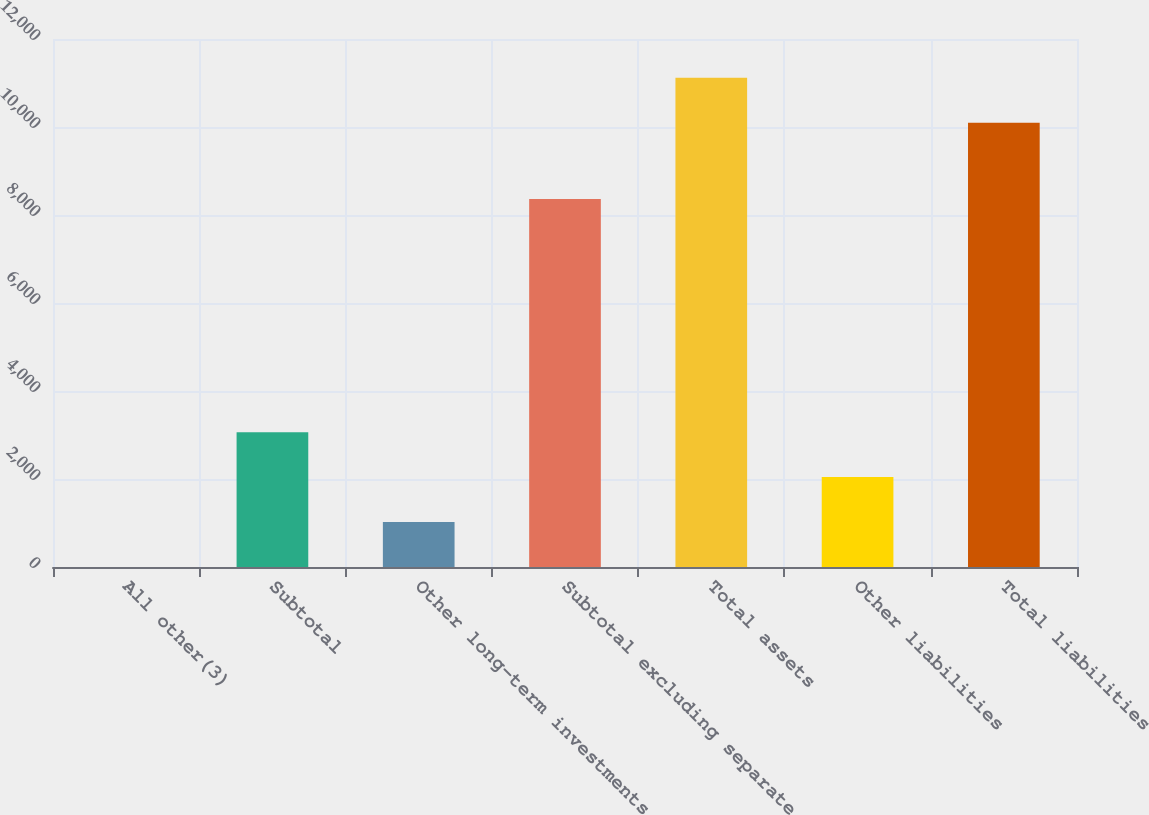Convert chart. <chart><loc_0><loc_0><loc_500><loc_500><bar_chart><fcel>All other(3)<fcel>Subtotal<fcel>Other long-term investments<fcel>Subtotal excluding separate<fcel>Total assets<fcel>Other liabilities<fcel>Total liabilities<nl><fcel>1<fcel>3064.9<fcel>1022.3<fcel>8365<fcel>11120.3<fcel>2043.6<fcel>10099<nl></chart> 